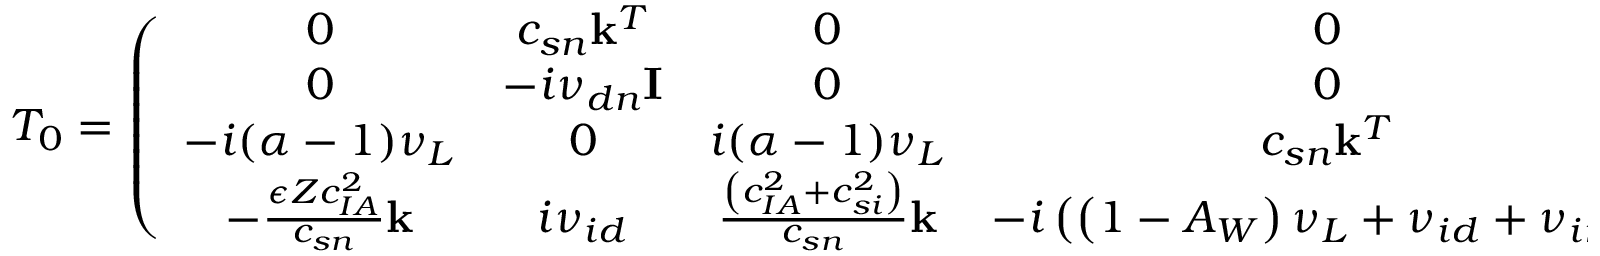<formula> <loc_0><loc_0><loc_500><loc_500>T _ { 0 } = \left ( \begin{array} { c c c c } { 0 } & { c _ { s n } k ^ { T } } & { 0 } & { 0 } \\ { 0 } & { - i \nu _ { d n } I } & { 0 } & { 0 } \\ { - i ( \alpha - 1 ) \nu _ { L } } & { 0 } & { i ( \alpha - 1 ) \nu _ { L } } & { c _ { s n } k ^ { T } } \\ { - \frac { \epsilon Z c _ { I A } ^ { 2 } } { c _ { s n } } k } & { i \nu _ { i d } } & { \frac { \left ( c _ { I A } ^ { 2 } + c _ { s i } ^ { 2 } \right ) } { c _ { s n } } k } & { - i \left ( \left ( 1 - A _ { W } \right ) \nu _ { L } + \nu _ { i d } + \nu _ { i n } \right ) I } \end{array} \right ) , \quad T _ { 1 } = \left ( \begin{array} { c c c c } { 0 } & { 0 } & { 0 } & { 0 } \\ { \frac { \epsilon ^ { 2 } Z ^ { 2 } c _ { I A } ^ { 2 } } { c _ { s n } } k } & { - i \nu _ { i d } I } & { - \frac { \epsilon Z c _ { I A } ^ { 2 } } { c _ { s n } } k } & { i \nu _ { i d } I } \\ { 0 } & { 0 } & { 0 } & { 0 } \\ { 0 } & { 0 } & { 0 } & { 0 } \end{array} \right )</formula> 